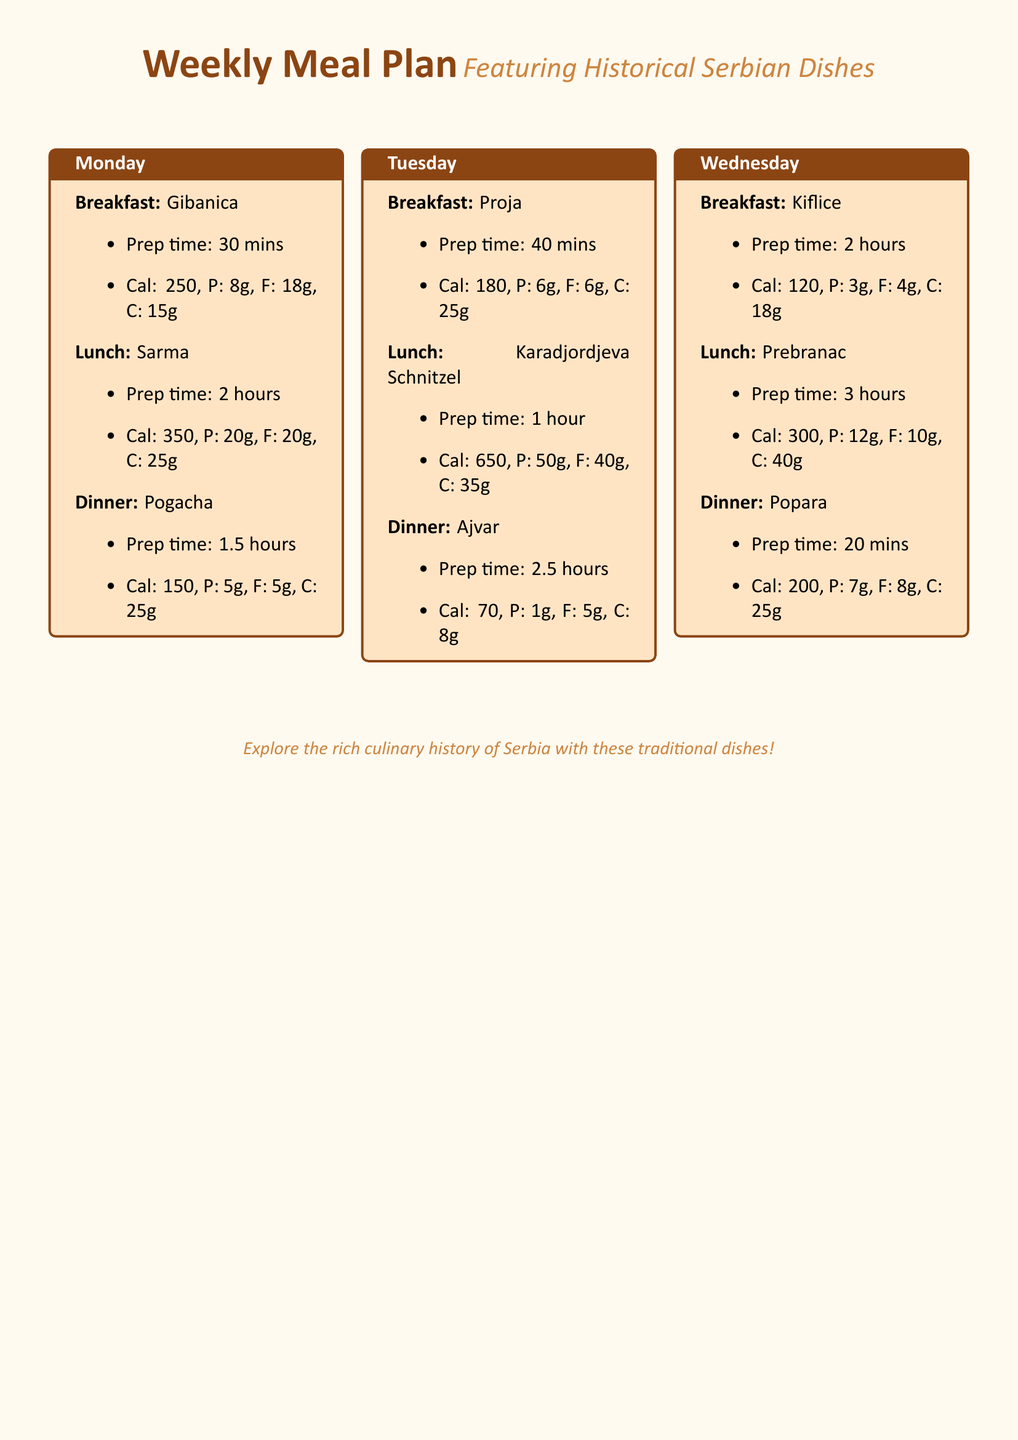What is the breakfast dish for Monday? The breakfast dish listed for Monday is Gibanica.
Answer: Gibanica How long does it take to prepare Sarma? The document states that the preparation time for Sarma is 2 hours.
Answer: 2 hours What is the total calorie count for lunch on Tuesday? The lunch dish for Tuesday is Karadjordjeva Schnitzel, which has a calorie count of 650.
Answer: 650 Which dish has the least calories for dinner? Among the dinner options, Ajvar has the least calories with 70.
Answer: Ajvar What is the protein content of Prebranac? The protein content for Prebranac, listed under lunch for Wednesday, is 12g.
Answer: 12g Which day's dinner has the shortest preparation time? The dinner that requires the least amount of time to prepare is Popara at 20 mins.
Answer: 20 mins What traditional dish is featured for lunch on Wednesday? The lunch dish featured on Wednesday is Prebranac.
Answer: Prebranac What is the preparation time for breakfast on Tuesday? The preparation time for breakfast on Tuesday is 40 mins.
Answer: 40 mins How many grams of carbohydrates does Gibanica contain? Gibanica contains 15g of carbohydrates.
Answer: 15g 